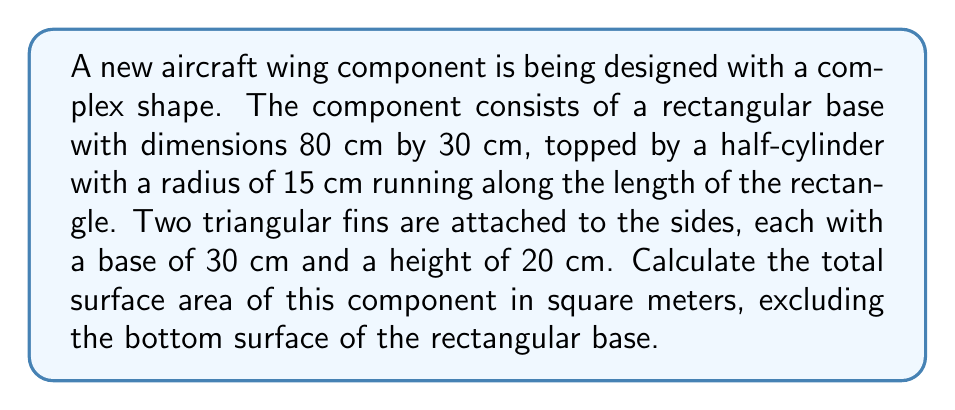Give your solution to this math problem. Let's break this down step-by-step:

1. Rectangular base (top and sides only):
   Area = $2(l \times w) + 2(l \times h)$
   $$ A_{rect} = 2(80 \times 30) + 2(80 \times 15) = 4800 + 2400 = 7200 \text{ cm}^2 $$

2. Half-cylinder surface:
   Area = $\frac{1}{2} \times 2\pi r l$
   $$ A_{cyl} = \frac{1}{2} \times 2\pi \times 15 \times 80 = 3770.35 \text{ cm}^2 $$

3. Triangular fins (two of them):
   Area of one triangle = $\frac{1}{2} \times base \times height$
   $$ A_{tri} = 2 \times (\frac{1}{2} \times 30 \times 20) = 600 \text{ cm}^2 $$

4. Total surface area:
   $$ A_{total} = A_{rect} + A_{cyl} + A_{tri} $$
   $$ A_{total} = 7200 + 3770.35 + 600 = 11570.35 \text{ cm}^2 $$

5. Convert to square meters:
   $$ A_{total} = 11570.35 \times 10^{-4} = 1.157035 \text{ m}^2 $$
Answer: $1.16 \text{ m}^2$ 